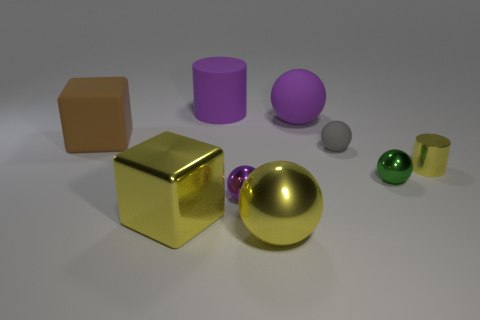Subtract all blue cubes. How many purple balls are left? 2 Subtract all yellow spheres. How many spheres are left? 4 Add 1 large brown blocks. How many objects exist? 10 Subtract all yellow spheres. How many spheres are left? 4 Subtract all blue spheres. Subtract all yellow cylinders. How many spheres are left? 5 Subtract all spheres. How many objects are left? 4 Subtract 1 green spheres. How many objects are left? 8 Subtract all small green objects. Subtract all brown objects. How many objects are left? 7 Add 2 tiny metal objects. How many tiny metal objects are left? 5 Add 3 tiny gray matte objects. How many tiny gray matte objects exist? 4 